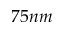<formula> <loc_0><loc_0><loc_500><loc_500>7 5 n m</formula> 